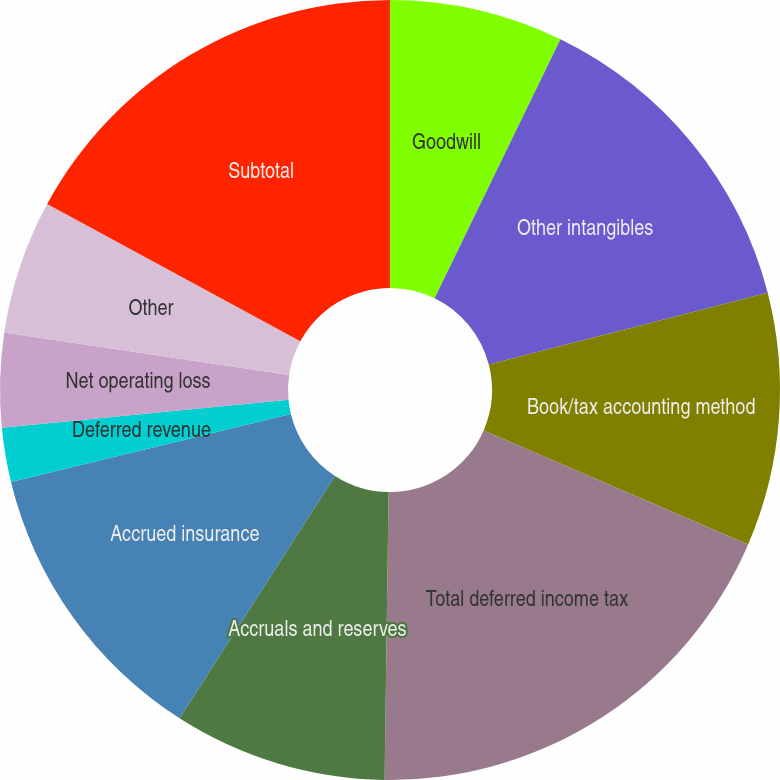<chart> <loc_0><loc_0><loc_500><loc_500><pie_chart><fcel>Goodwill<fcel>Other intangibles<fcel>Book/tax accounting method<fcel>Total deferred income tax<fcel>Accruals and reserves<fcel>Accrued insurance<fcel>Deferred revenue<fcel>Net operating loss<fcel>Other<fcel>Subtotal<nl><fcel>7.2%<fcel>13.79%<fcel>10.49%<fcel>18.74%<fcel>8.85%<fcel>12.14%<fcel>2.25%<fcel>3.9%<fcel>5.55%<fcel>17.09%<nl></chart> 